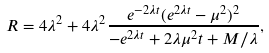<formula> <loc_0><loc_0><loc_500><loc_500>R = 4 \lambda ^ { 2 } + 4 \lambda ^ { 2 } \frac { e ^ { - 2 \lambda t } ( e ^ { 2 \lambda t } - \mu ^ { 2 } ) ^ { 2 } } { - e ^ { 2 \lambda t } + 2 \lambda \mu ^ { 2 } t + M / \lambda } ,</formula> 